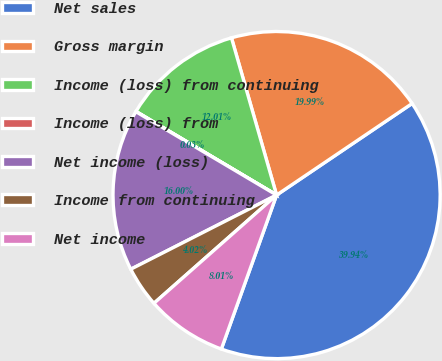<chart> <loc_0><loc_0><loc_500><loc_500><pie_chart><fcel>Net sales<fcel>Gross margin<fcel>Income (loss) from continuing<fcel>Income (loss) from<fcel>Net income (loss)<fcel>Income from continuing<fcel>Net income<nl><fcel>39.94%<fcel>19.99%<fcel>12.01%<fcel>0.03%<fcel>16.0%<fcel>4.02%<fcel>8.01%<nl></chart> 